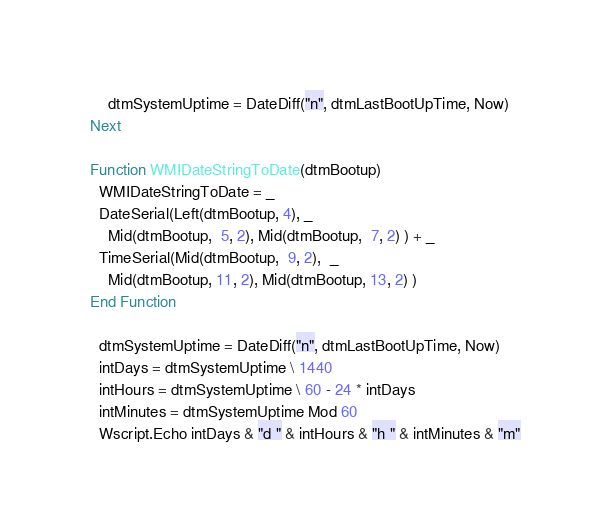<code> <loc_0><loc_0><loc_500><loc_500><_VisualBasic_>    dtmSystemUptime = DateDiff("n", dtmLastBootUpTime, Now)
Next

Function WMIDateStringToDate(dtmBootup)
  WMIDateStringToDate = _
  DateSerial(Left(dtmBootup, 4), _
    Mid(dtmBootup,  5, 2), Mid(dtmBootup,  7, 2) ) + _
  TimeSerial(Mid(dtmBootup,  9, 2),  _
    Mid(dtmBootup, 11, 2), Mid(dtmBootup, 13, 2) )
End Function

  dtmSystemUptime = DateDiff("n", dtmLastBootUpTime, Now)
  intDays = dtmSystemUptime \ 1440
  intHours = dtmSystemUptime \ 60 - 24 * intDays
  intMinutes = dtmSystemUptime Mod 60
  Wscript.Echo intDays & "d " & intHours & "h " & intMinutes & "m"</code> 